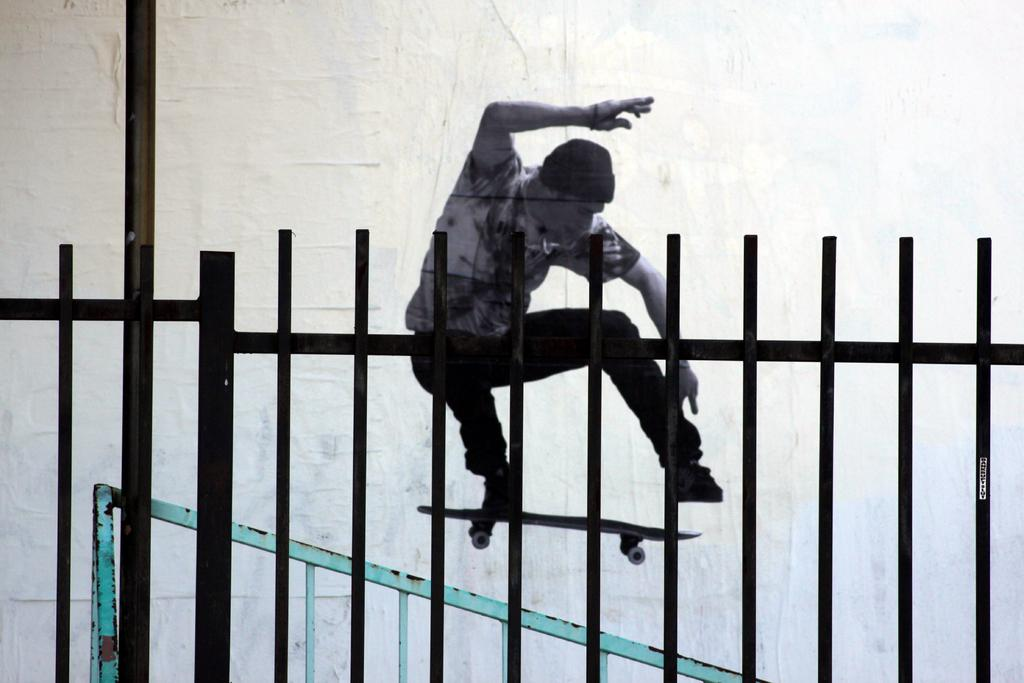What type of barrier is present in the image? There is a metal fence in the image. What activity is the man behind the fence engaged in? The man is doing skating behind the fence. What type of rest is the man taking while skating in the image? The man is not taking any rest while skating in the image; he is actively engaged in the activity. Is the man sailing on a boat in the image? No, the man is not sailing on a boat in the image; he is skating behind a metal fence. 